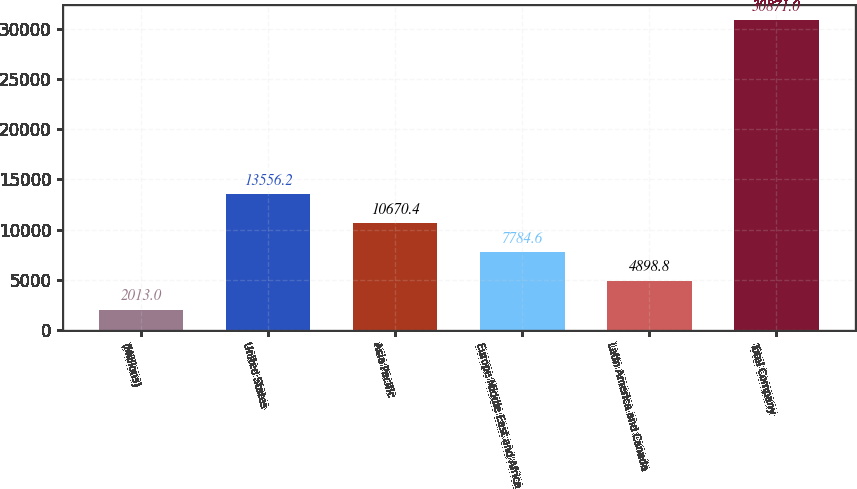Convert chart to OTSL. <chart><loc_0><loc_0><loc_500><loc_500><bar_chart><fcel>(Millions)<fcel>United States<fcel>Asia Pacific<fcel>Europe Middle East and Africa<fcel>Latin America and Canada<fcel>Total Company<nl><fcel>2013<fcel>13556.2<fcel>10670.4<fcel>7784.6<fcel>4898.8<fcel>30871<nl></chart> 